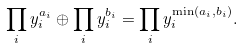Convert formula to latex. <formula><loc_0><loc_0><loc_500><loc_500>\prod _ { i } y _ { i } ^ { a _ { i } } \oplus \prod _ { i } y _ { i } ^ { b _ { i } } = \prod _ { i } y _ { i } ^ { \min ( a _ { i } , b _ { i } ) } .</formula> 